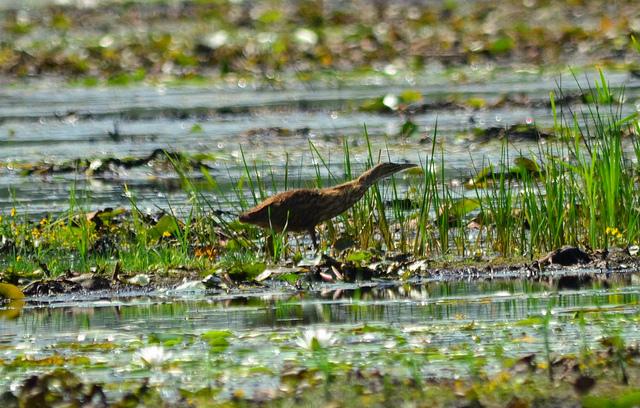What is around the bird?
Keep it brief. Water. What kind of bird is it?
Give a very brief answer. Pigeon. What kind of animal is shown?
Answer briefly. Bird. 